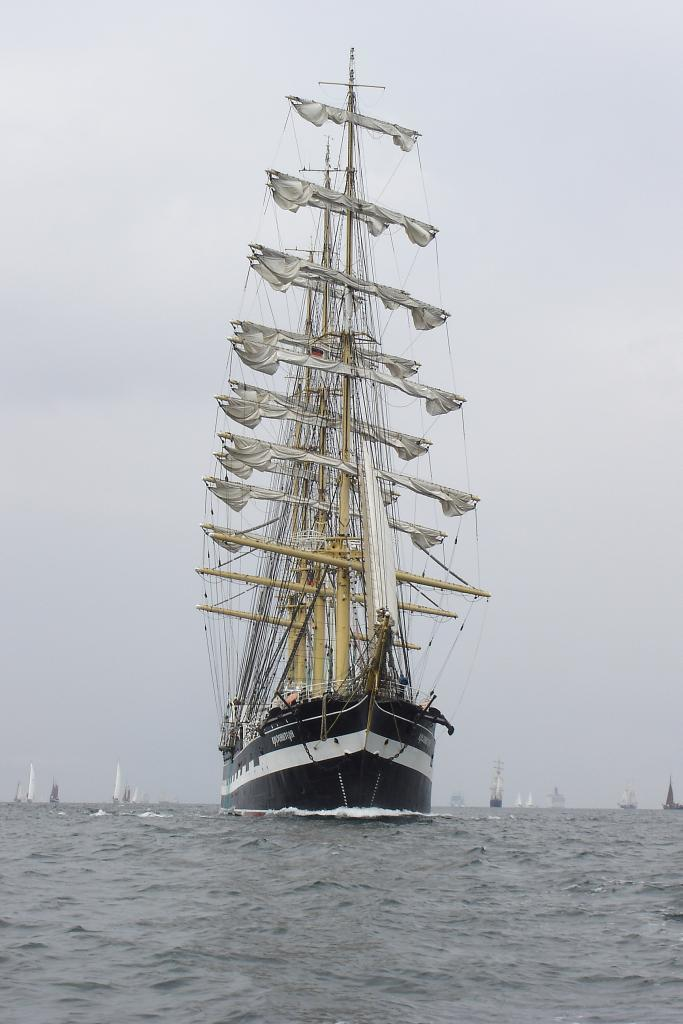What is the main subject of the image? The main subject of the image is a ship. What colors are used to paint the ship? The ship is black, white, and cream in color. Where is the ship located in the image? The ship is on the surface of the water. What else can be seen in the background of the image? There are boats and the sky visible in the background of the image. Can you tell me how many loaves of bread are on the ship in the image? There is no bread present on the ship in the image. Is the ship hot or cold in the image? The image does not provide information about the temperature of the ship, so it cannot be determined if the ship is hot or cold. 